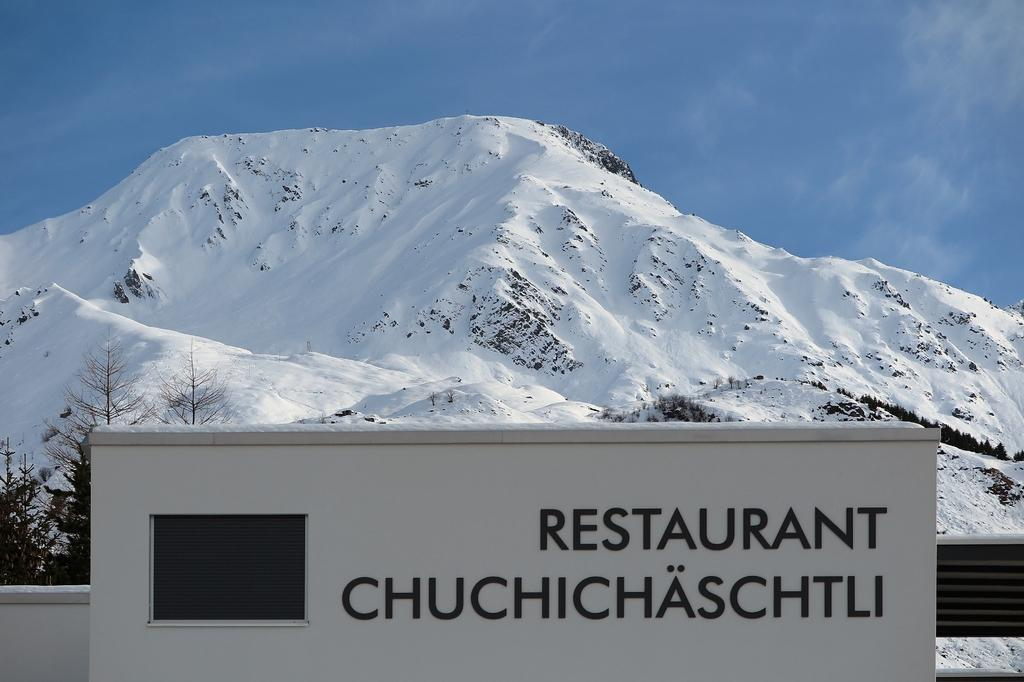<image>
Create a compact narrative representing the image presented. A sign of a restaurant near snow covered mountain tops 